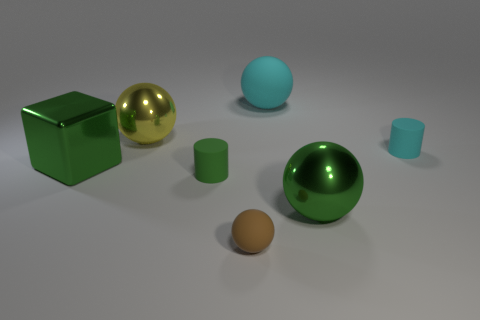The large ball left of the cyan matte ball is what color?
Offer a very short reply. Yellow. There is a rubber cylinder to the left of the large rubber thing; are there any tiny brown balls that are behind it?
Offer a terse response. No. There is a large cube; is its color the same as the big metallic thing that is in front of the metallic block?
Provide a short and direct response. Yes. Is there a large yellow ball that has the same material as the block?
Keep it short and to the point. Yes. How many tiny brown matte balls are there?
Keep it short and to the point. 1. What material is the small thing to the right of the green metallic object in front of the metallic block?
Your answer should be very brief. Rubber. What is the color of the other ball that is the same material as the big cyan sphere?
Offer a very short reply. Brown. There is a matte thing that is the same color as the shiny cube; what is its shape?
Provide a short and direct response. Cylinder. There is a cyan rubber object to the right of the large cyan ball; is its size the same as the shiny cube that is on the left side of the small cyan rubber thing?
Your response must be concise. No. What number of balls are either big green metal things or tiny brown matte objects?
Keep it short and to the point. 2. 